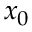<formula> <loc_0><loc_0><loc_500><loc_500>x _ { 0 }</formula> 